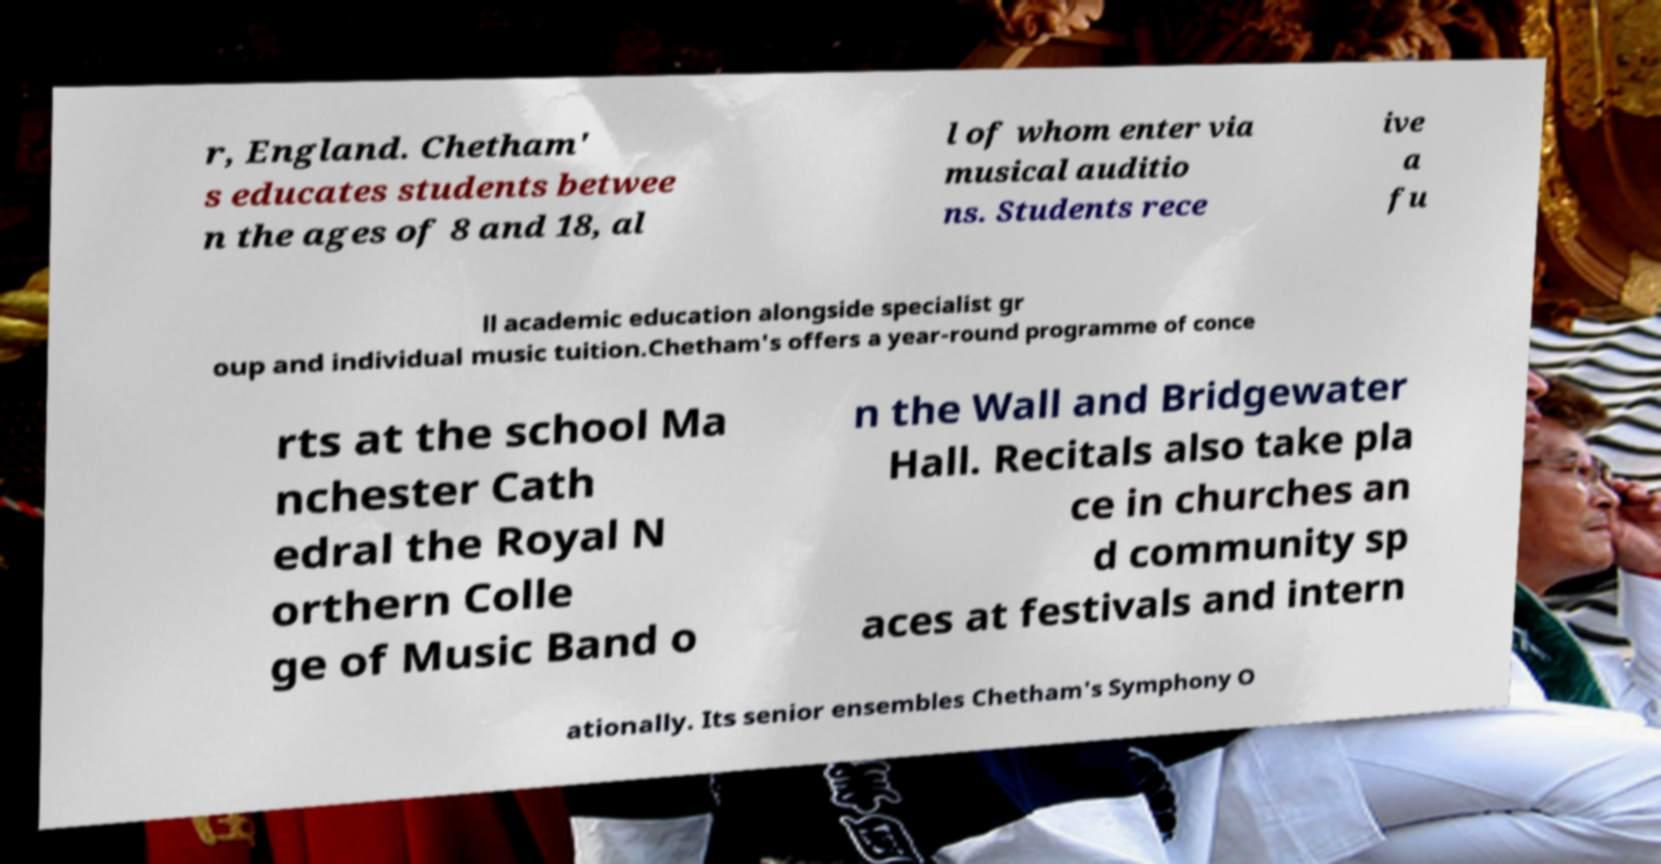There's text embedded in this image that I need extracted. Can you transcribe it verbatim? r, England. Chetham' s educates students betwee n the ages of 8 and 18, al l of whom enter via musical auditio ns. Students rece ive a fu ll academic education alongside specialist gr oup and individual music tuition.Chetham's offers a year-round programme of conce rts at the school Ma nchester Cath edral the Royal N orthern Colle ge of Music Band o n the Wall and Bridgewater Hall. Recitals also take pla ce in churches an d community sp aces at festivals and intern ationally. Its senior ensembles Chetham's Symphony O 